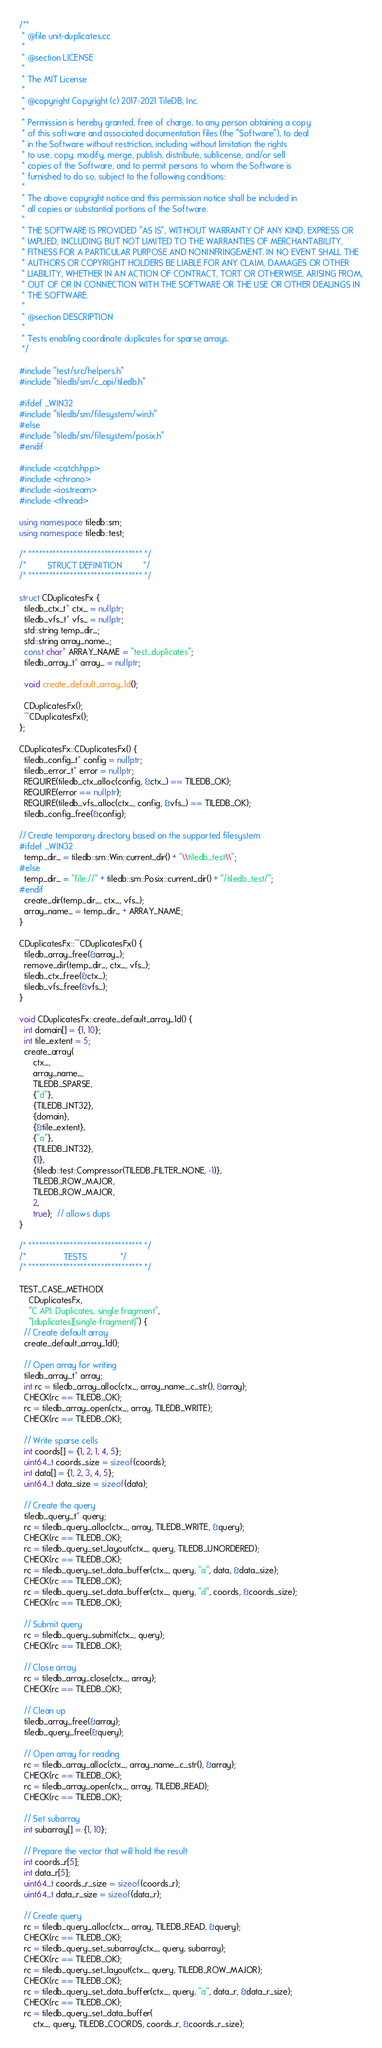<code> <loc_0><loc_0><loc_500><loc_500><_C++_>/**
 * @file unit-duplicates.cc
 *
 * @section LICENSE
 *
 * The MIT License
 *
 * @copyright Copyright (c) 2017-2021 TileDB, Inc.
 *
 * Permission is hereby granted, free of charge, to any person obtaining a copy
 * of this software and associated documentation files (the "Software"), to deal
 * in the Software without restriction, including without limitation the rights
 * to use, copy, modify, merge, publish, distribute, sublicense, and/or sell
 * copies of the Software, and to permit persons to whom the Software is
 * furnished to do so, subject to the following conditions:
 *
 * The above copyright notice and this permission notice shall be included in
 * all copies or substantial portions of the Software.
 *
 * THE SOFTWARE IS PROVIDED "AS IS", WITHOUT WARRANTY OF ANY KIND, EXPRESS OR
 * IMPLIED, INCLUDING BUT NOT LIMITED TO THE WARRANTIES OF MERCHANTABILITY,
 * FITNESS FOR A PARTICULAR PURPOSE AND NONINFRINGEMENT. IN NO EVENT SHALL THE
 * AUTHORS OR COPYRIGHT HOLDERS BE LIABLE FOR ANY CLAIM, DAMAGES OR OTHER
 * LIABILITY, WHETHER IN AN ACTION OF CONTRACT, TORT OR OTHERWISE, ARISING FROM,
 * OUT OF OR IN CONNECTION WITH THE SOFTWARE OR THE USE OR OTHER DEALINGS IN
 * THE SOFTWARE.
 *
 * @section DESCRIPTION
 *
 * Tests enabling coordinate duplicates for sparse arrays.
 */

#include "test/src/helpers.h"
#include "tiledb/sm/c_api/tiledb.h"

#ifdef _WIN32
#include "tiledb/sm/filesystem/win.h"
#else
#include "tiledb/sm/filesystem/posix.h"
#endif

#include <catch.hpp>
#include <chrono>
#include <iostream>
#include <thread>

using namespace tiledb::sm;
using namespace tiledb::test;

/* ********************************* */
/*         STRUCT DEFINITION         */
/* ********************************* */

struct CDuplicatesFx {
  tiledb_ctx_t* ctx_ = nullptr;
  tiledb_vfs_t* vfs_ = nullptr;
  std::string temp_dir_;
  std::string array_name_;
  const char* ARRAY_NAME = "test_duplicates";
  tiledb_array_t* array_ = nullptr;

  void create_default_array_1d();

  CDuplicatesFx();
  ~CDuplicatesFx();
};

CDuplicatesFx::CDuplicatesFx() {
  tiledb_config_t* config = nullptr;
  tiledb_error_t* error = nullptr;
  REQUIRE(tiledb_ctx_alloc(config, &ctx_) == TILEDB_OK);
  REQUIRE(error == nullptr);
  REQUIRE(tiledb_vfs_alloc(ctx_, config, &vfs_) == TILEDB_OK);
  tiledb_config_free(&config);

// Create temporary directory based on the supported filesystem
#ifdef _WIN32
  temp_dir_ = tiledb::sm::Win::current_dir() + "\\tiledb_test\\";
#else
  temp_dir_ = "file://" + tiledb::sm::Posix::current_dir() + "/tiledb_test/";
#endif
  create_dir(temp_dir_, ctx_, vfs_);
  array_name_ = temp_dir_ + ARRAY_NAME;
}

CDuplicatesFx::~CDuplicatesFx() {
  tiledb_array_free(&array_);
  remove_dir(temp_dir_, ctx_, vfs_);
  tiledb_ctx_free(&ctx_);
  tiledb_vfs_free(&vfs_);
}

void CDuplicatesFx::create_default_array_1d() {
  int domain[] = {1, 10};
  int tile_extent = 5;
  create_array(
      ctx_,
      array_name_,
      TILEDB_SPARSE,
      {"d"},
      {TILEDB_INT32},
      {domain},
      {&tile_extent},
      {"a"},
      {TILEDB_INT32},
      {1},
      {tiledb::test::Compressor(TILEDB_FILTER_NONE, -1)},
      TILEDB_ROW_MAJOR,
      TILEDB_ROW_MAJOR,
      2,
      true);  // allows dups
}

/* ********************************* */
/*                TESTS              */
/* ********************************* */

TEST_CASE_METHOD(
    CDuplicatesFx,
    "C API: Duplicates, single fragment",
    "[duplicates][single-fragment]") {
  // Create default array
  create_default_array_1d();

  // Open array for writing
  tiledb_array_t* array;
  int rc = tiledb_array_alloc(ctx_, array_name_.c_str(), &array);
  CHECK(rc == TILEDB_OK);
  rc = tiledb_array_open(ctx_, array, TILEDB_WRITE);
  CHECK(rc == TILEDB_OK);

  // Write sparse cells
  int coords[] = {1, 2, 1, 4, 5};
  uint64_t coords_size = sizeof(coords);
  int data[] = {1, 2, 3, 4, 5};
  uint64_t data_size = sizeof(data);

  // Create the query
  tiledb_query_t* query;
  rc = tiledb_query_alloc(ctx_, array, TILEDB_WRITE, &query);
  CHECK(rc == TILEDB_OK);
  rc = tiledb_query_set_layout(ctx_, query, TILEDB_UNORDERED);
  CHECK(rc == TILEDB_OK);
  rc = tiledb_query_set_data_buffer(ctx_, query, "a", data, &data_size);
  CHECK(rc == TILEDB_OK);
  rc = tiledb_query_set_data_buffer(ctx_, query, "d", coords, &coords_size);
  CHECK(rc == TILEDB_OK);

  // Submit query
  rc = tiledb_query_submit(ctx_, query);
  CHECK(rc == TILEDB_OK);

  // Close array
  rc = tiledb_array_close(ctx_, array);
  CHECK(rc == TILEDB_OK);

  // Clean up
  tiledb_array_free(&array);
  tiledb_query_free(&query);

  // Open array for reading
  rc = tiledb_array_alloc(ctx_, array_name_.c_str(), &array);
  CHECK(rc == TILEDB_OK);
  rc = tiledb_array_open(ctx_, array, TILEDB_READ);
  CHECK(rc == TILEDB_OK);

  // Set subarray
  int subarray[] = {1, 10};

  // Prepare the vector that will hold the result
  int coords_r[5];
  int data_r[5];
  uint64_t coords_r_size = sizeof(coords_r);
  uint64_t data_r_size = sizeof(data_r);

  // Create query
  rc = tiledb_query_alloc(ctx_, array, TILEDB_READ, &query);
  CHECK(rc == TILEDB_OK);
  rc = tiledb_query_set_subarray(ctx_, query, subarray);
  CHECK(rc == TILEDB_OK);
  rc = tiledb_query_set_layout(ctx_, query, TILEDB_ROW_MAJOR);
  CHECK(rc == TILEDB_OK);
  rc = tiledb_query_set_data_buffer(ctx_, query, "a", data_r, &data_r_size);
  CHECK(rc == TILEDB_OK);
  rc = tiledb_query_set_data_buffer(
      ctx_, query, TILEDB_COORDS, coords_r, &coords_r_size);</code> 